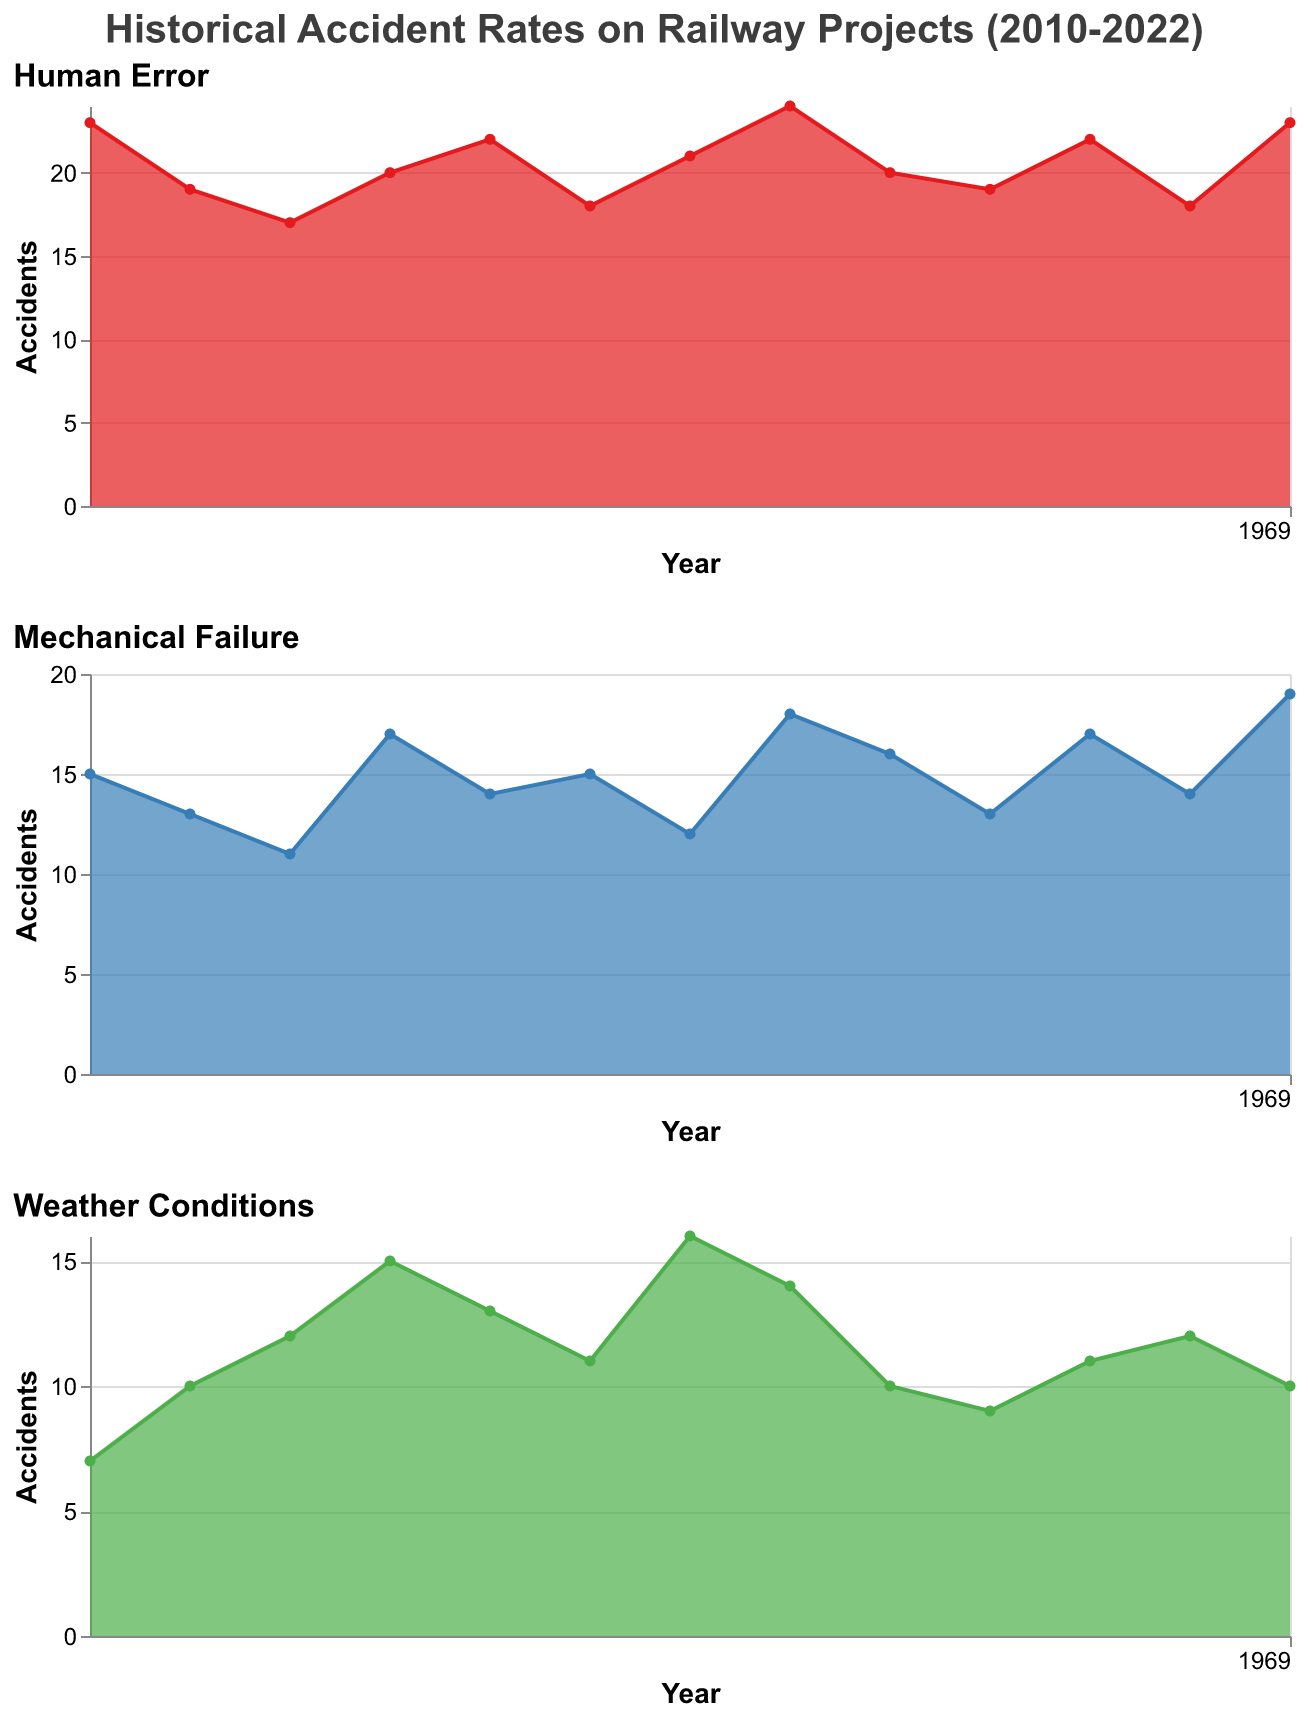What is the title of the figure? The title is displayed at the top of the figure in a bold font and provides an overall description of the data presented.
Answer: "Historical Accident Rates on Railway Projects (2010-2022)" Which type of accidents have the highest rates in 2017? By visually inspecting the three area charts for the year 2017, the Human Error chart shows the highest peak compared to the other two charts.
Answer: Human Error How many accidents were caused by Mechanical Failure in 2012? Locate the value on the Mechanical Failure chart for the year 2012, indicated by the area chart's point.
Answer: 11 In which year did Weather Conditions cause the most accidents? Compare the heights of the area in the Weather Conditions subplot across all years; the highest point in 2016 represents the peak.
Answer: 2016 Which type of accidents saw a decreasing trend from 2013 to 2015? Examine each subplot for the trend between the years 2013 and 2015, and observe the direction of the lines. Both Human Error and Weather Conditions decrease, but Human Error is more prominent.
Answer: Human Error What is the total number of Weather-related accidents in 2016 and 2022 combined? Add the number of Weather Conditions accidents for the years 2016 (16 accidents) and 2022 (10 accidents): 16 + 10.
Answer: 26 Compare the number of Human Error accidents in 2010 with Weather Conditions accidents in 2022. Which is higher? Locate the values for these years on their respective charts: Human Error in 2010 (23 accidents) and Weather Conditions in 2022 (10 accidents).
Answer: Human Error in 2010 What has been the trend of Mechanical Failure accidents from 2010 to 2022? Observe the overall direction and pattern of the line in the Mechanical Failure subplot, noting it generally increases with some fluctuations.
Answer: Increasing trend with fluctuations How do the accident rates of Mechanical Failure and Weather Conditions in 2013 compare? Find the values for 2013 in Mechanical Failure (17 accidents) and Weather Conditions (15 accidents). The Mechanical Failure rate is higher.
Answer: Mechanical Failure is higher What is the average number of Human Error accidents between 2010 and 2015? Calculate the average by adding the Human Error accidents from 2010 to 2015 (23 + 19 + 17 + 20 + 22 + 18) and dividing by 6: (23+19+17+20+22+18)/6.
Answer: 19.83 